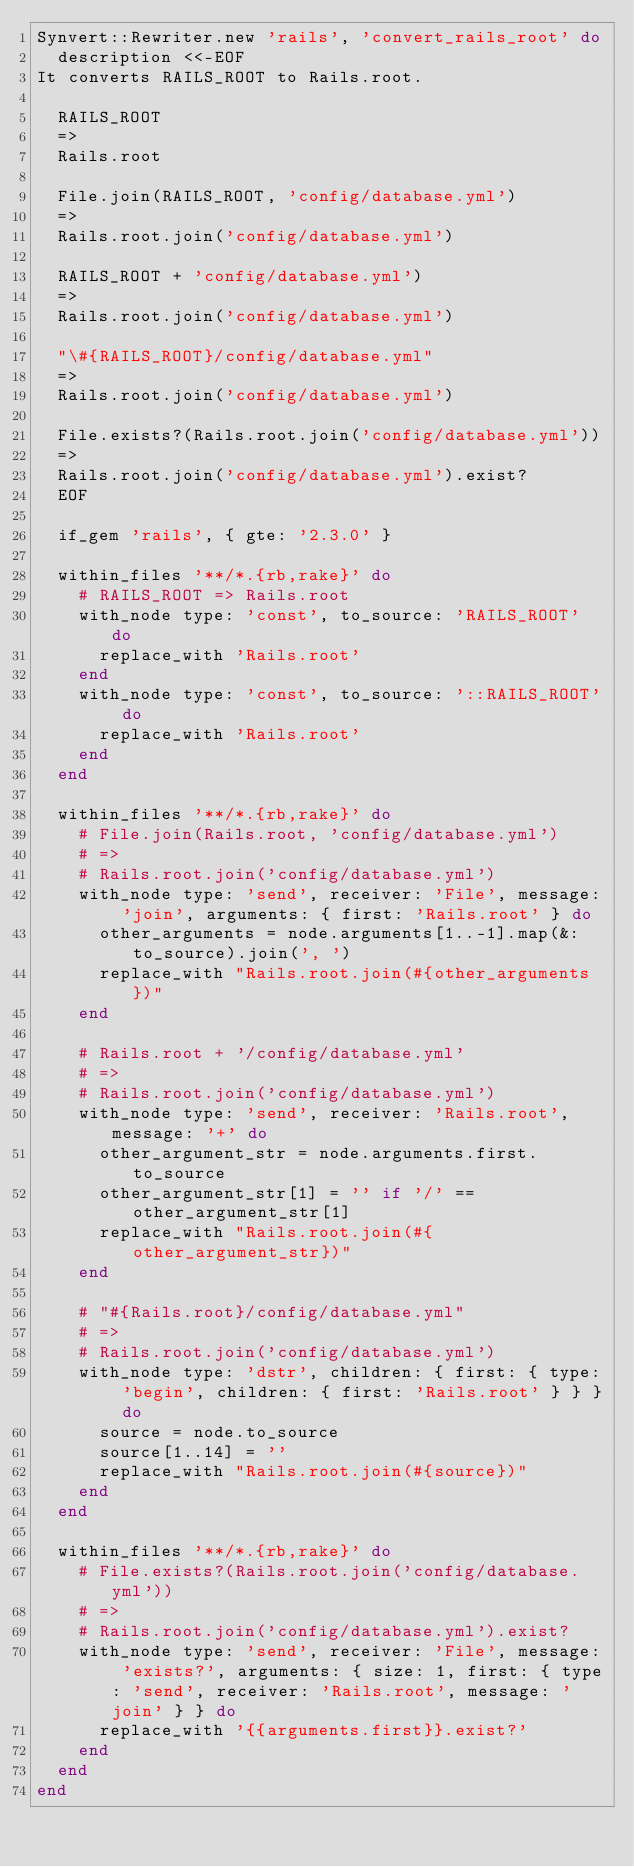Convert code to text. <code><loc_0><loc_0><loc_500><loc_500><_Ruby_>Synvert::Rewriter.new 'rails', 'convert_rails_root' do
  description <<-EOF
It converts RAILS_ROOT to Rails.root.

  RAILS_ROOT
  =>
  Rails.root

  File.join(RAILS_ROOT, 'config/database.yml')
  =>
  Rails.root.join('config/database.yml')

  RAILS_ROOT + 'config/database.yml')
  =>
  Rails.root.join('config/database.yml')

  "\#{RAILS_ROOT}/config/database.yml"
  =>
  Rails.root.join('config/database.yml')

  File.exists?(Rails.root.join('config/database.yml'))
  =>
  Rails.root.join('config/database.yml').exist?
  EOF

  if_gem 'rails', { gte: '2.3.0' }

  within_files '**/*.{rb,rake}' do
    # RAILS_ROOT => Rails.root
    with_node type: 'const', to_source: 'RAILS_ROOT' do
      replace_with 'Rails.root'
    end
    with_node type: 'const', to_source: '::RAILS_ROOT' do
      replace_with 'Rails.root'
    end
  end

  within_files '**/*.{rb,rake}' do
    # File.join(Rails.root, 'config/database.yml')
    # =>
    # Rails.root.join('config/database.yml')
    with_node type: 'send', receiver: 'File', message: 'join', arguments: { first: 'Rails.root' } do
      other_arguments = node.arguments[1..-1].map(&:to_source).join(', ')
      replace_with "Rails.root.join(#{other_arguments})"
    end

    # Rails.root + '/config/database.yml'
    # =>
    # Rails.root.join('config/database.yml')
    with_node type: 'send', receiver: 'Rails.root', message: '+' do
      other_argument_str = node.arguments.first.to_source
      other_argument_str[1] = '' if '/' == other_argument_str[1]
      replace_with "Rails.root.join(#{other_argument_str})"
    end

    # "#{Rails.root}/config/database.yml"
    # =>
    # Rails.root.join('config/database.yml')
    with_node type: 'dstr', children: { first: { type: 'begin', children: { first: 'Rails.root' } } } do
      source = node.to_source
      source[1..14] = ''
      replace_with "Rails.root.join(#{source})"
    end
  end

  within_files '**/*.{rb,rake}' do
    # File.exists?(Rails.root.join('config/database.yml'))
    # =>
    # Rails.root.join('config/database.yml').exist?
    with_node type: 'send', receiver: 'File', message: 'exists?', arguments: { size: 1, first: { type: 'send', receiver: 'Rails.root', message: 'join' } } do
      replace_with '{{arguments.first}}.exist?'
    end
  end
end
</code> 